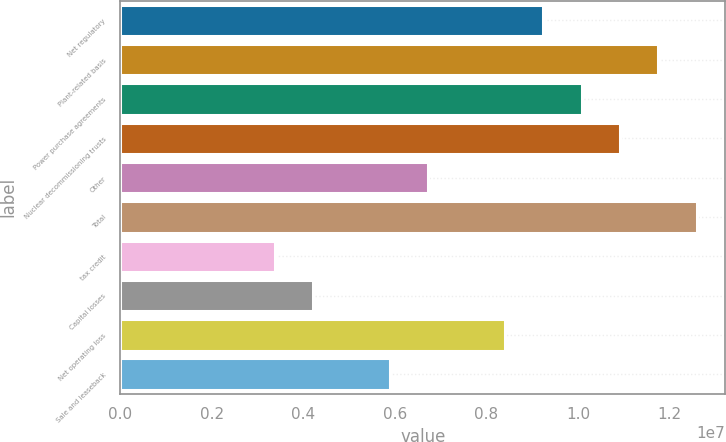Convert chart. <chart><loc_0><loc_0><loc_500><loc_500><bar_chart><fcel>Net regulatory<fcel>Plant-related basis<fcel>Power purchase agreements<fcel>Nuclear decommissioning trusts<fcel>Other<fcel>Total<fcel>tax credit<fcel>Capital losses<fcel>Net operating loss<fcel>Sale and leaseback<nl><fcel>9.23874e+06<fcel>1.17517e+07<fcel>1.00764e+07<fcel>1.0914e+07<fcel>6.72578e+06<fcel>1.25893e+07<fcel>3.37517e+06<fcel>4.21283e+06<fcel>8.40108e+06<fcel>5.88813e+06<nl></chart> 